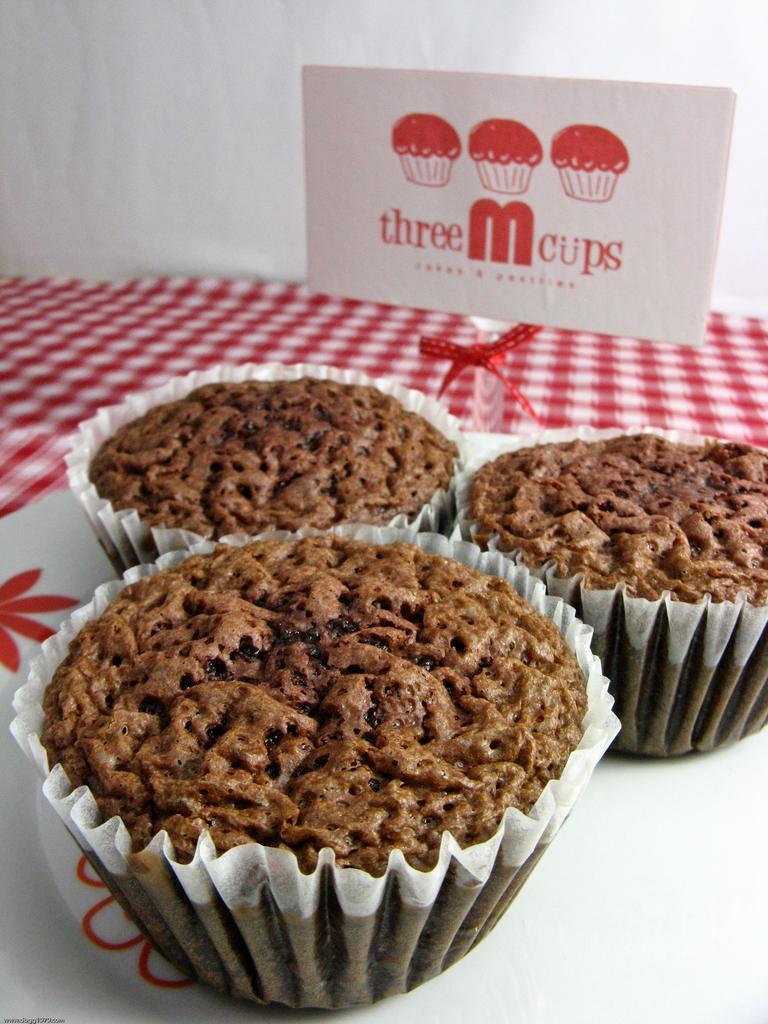How would you summarize this image in a sentence or two? This image consists of three cupcakes along with wrappers are kept on a plate. The plate is kept on a table. In the front, there is a small board. In the background, there is a wall. The table is covered with a red cloth. 